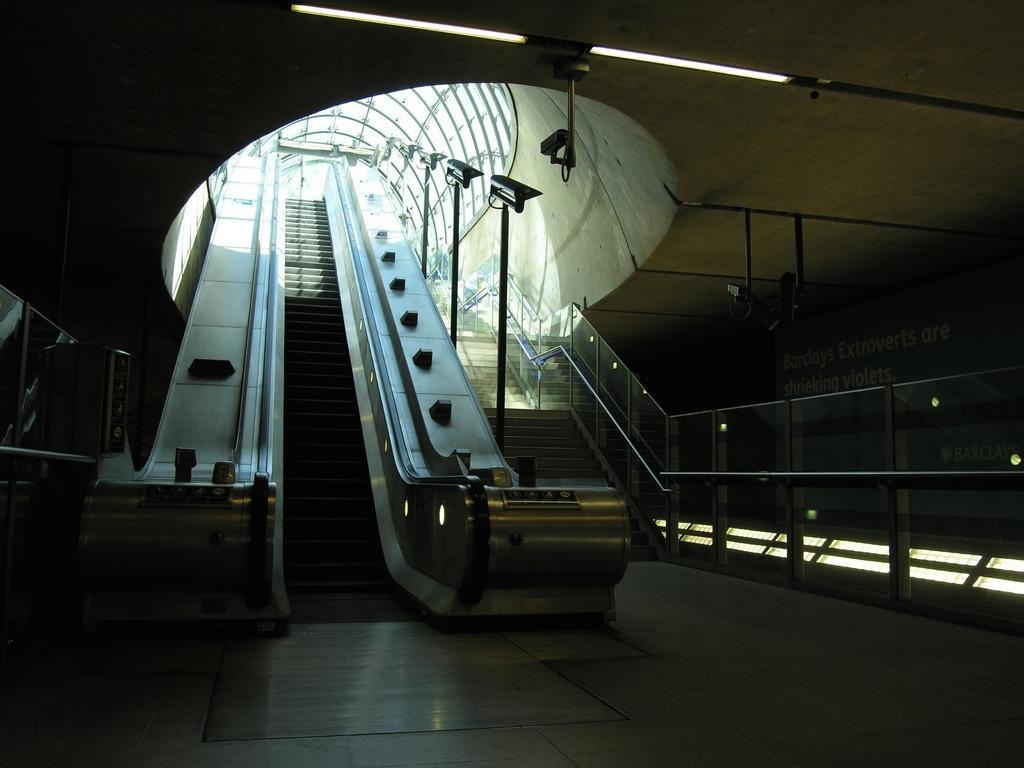How would you summarize this image in a sentence or two? This image is taken indoors. At the bottom of the image there is a floor. At the top of the image there is a roof with lights. In the middle of the image there is an escalator and a staircase with railings and iron bars. 